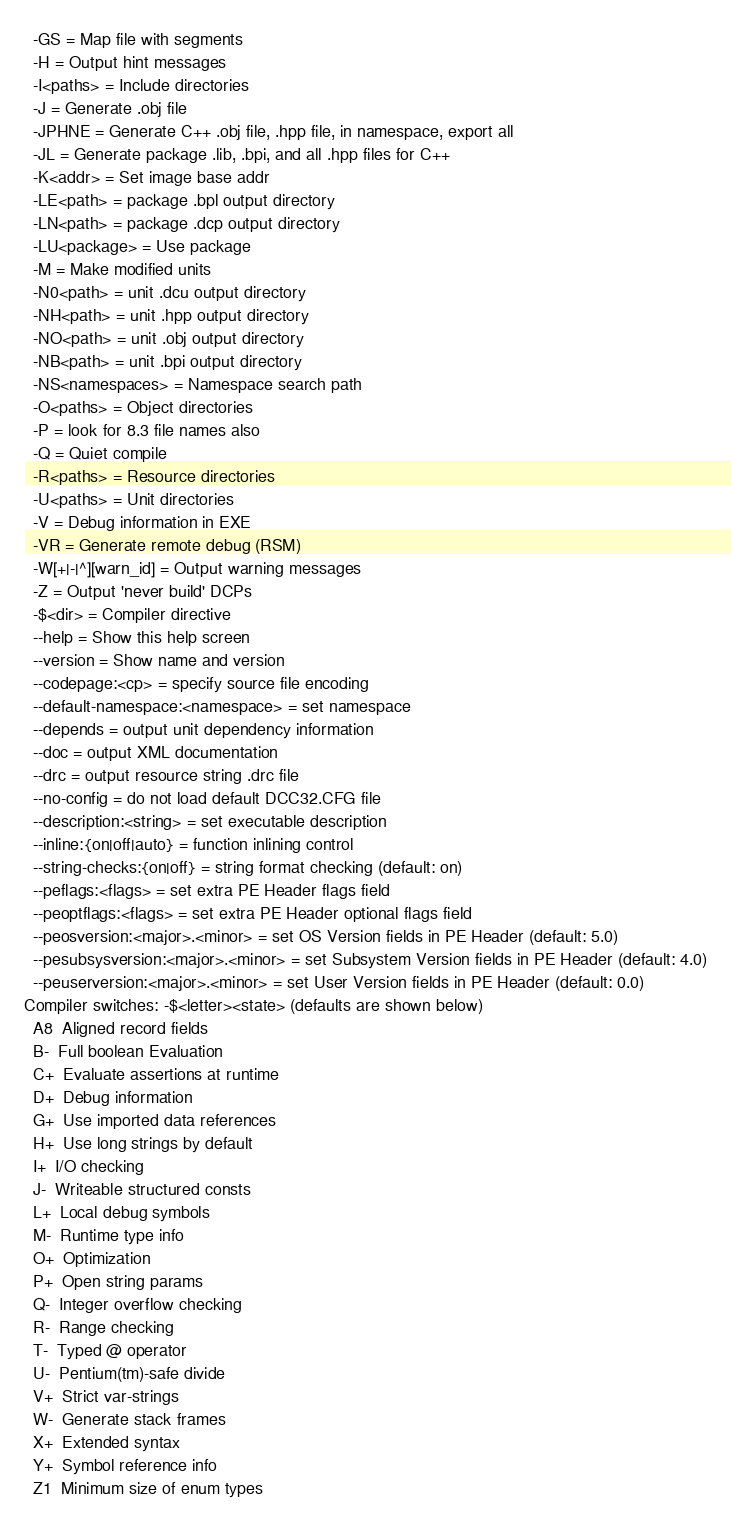Convert code to text. <code><loc_0><loc_0><loc_500><loc_500><_Perl_>  -GS = Map file with segments     
  -H = Output hint messages        
  -I<paths> = Include directories  
  -J = Generate .obj file          
  -JPHNE = Generate C++ .obj file, .hpp file, in namespace, export all
  -JL = Generate package .lib, .bpi, and all .hpp files for C++
  -K<addr> = Set image base addr   
  -LE<path> = package .bpl output directory
  -LN<path> = package .dcp output directory
  -LU<package> = Use package       
  -M = Make modified units         
  -N0<path> = unit .dcu output directory
  -NH<path> = unit .hpp output directory
  -NO<path> = unit .obj output directory
  -NB<path> = unit .bpi output directory
  -NS<namespaces> = Namespace search path
  -O<paths> = Object directories   
  -P = look for 8.3 file names also
  -Q = Quiet compile               
  -R<paths> = Resource directories 
  -U<paths> = Unit directories     
  -V = Debug information in EXE    
  -VR = Generate remote debug (RSM)
  -W[+|-|^][warn_id] = Output warning messages
  -Z = Output 'never build' DCPs   
  -$<dir> = Compiler directive     
  --help = Show this help screen   
  --version = Show name and version
  --codepage:<cp> = specify source file encoding
  --default-namespace:<namespace> = set namespace
  --depends = output unit dependency information
  --doc = output XML documentation 
  --drc = output resource string .drc file
  --no-config = do not load default DCC32.CFG file
  --description:<string> = set executable description
  --inline:{on|off|auto} = function inlining control
  --string-checks:{on|off} = string format checking (default: on)
  --peflags:<flags> = set extra PE Header flags field
  --peoptflags:<flags> = set extra PE Header optional flags field
  --peosversion:<major>.<minor> = set OS Version fields in PE Header (default: 5.0)
  --pesubsysversion:<major>.<minor> = set Subsystem Version fields in PE Header (default: 4.0)
  --peuserversion:<major>.<minor> = set User Version fields in PE Header (default: 0.0)
Compiler switches: -$<letter><state> (defaults are shown below)
  A8  Aligned record fields         
  B-  Full boolean Evaluation       
  C+  Evaluate assertions at runtime
  D+  Debug information             
  G+  Use imported data references  
  H+  Use long strings by default   
  I+  I/O checking                  
  J-  Writeable structured consts   
  L+  Local debug symbols           
  M-  Runtime type info             
  O+  Optimization                  
  P+  Open string params            
  Q-  Integer overflow checking     
  R-  Range checking                
  T-  Typed @ operator              
  U-  Pentium(tm)-safe divide       
  V+  Strict var-strings            
  W-  Generate stack frames         
  X+  Extended syntax               
  Y+  Symbol reference info         
  Z1  Minimum size of enum types    
</code> 